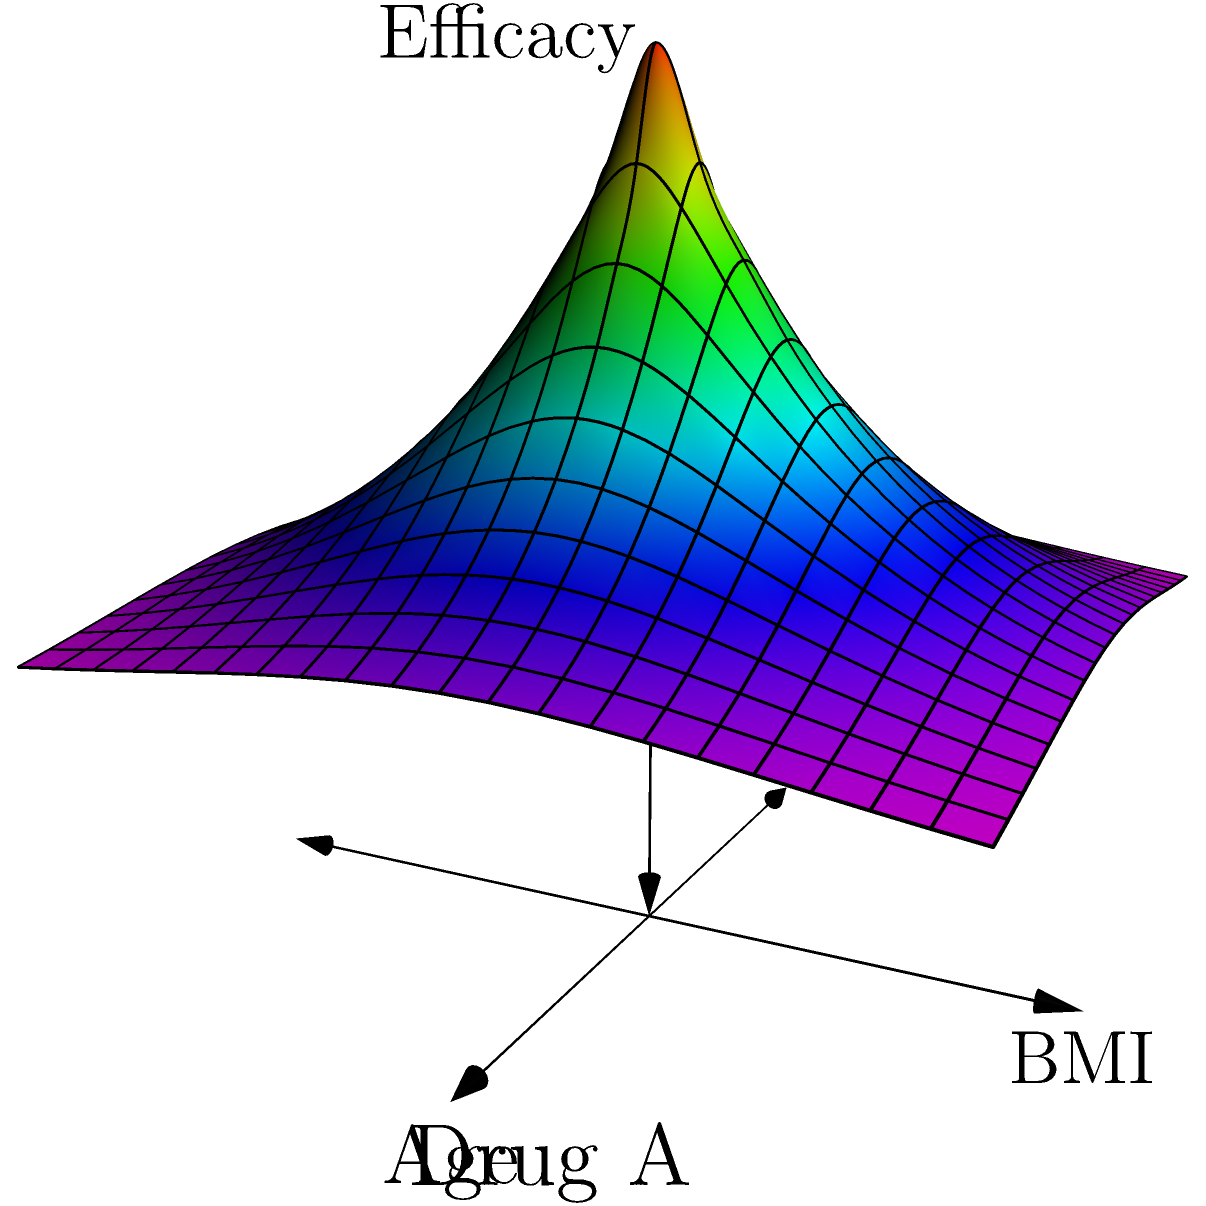In the multi-dimensional vector plot shown, which patient demographic characteristic appears to have the most significant impact on the efficacy of Drug A? To determine which patient demographic characteristic has the most significant impact on Drug A's efficacy, we need to analyze the 3D plot carefully:

1. The x-axis represents Age, the y-axis represents BMI (Body Mass Index), and the z-axis represents Efficacy.

2. The surface plot shows the relationship between these three variables for Drug A.

3. Observe the gradient of colors: 
   - Red indicates high efficacy
   - Blue indicates low efficacy

4. Looking at the age axis (x-axis):
   - There's a gradual change in efficacy as age increases or decreases
   - The change is relatively smooth and consistent

5. Examining the BMI axis (y-axis):
   - There's a more pronounced change in efficacy as BMI changes
   - The peak efficacy (red area) is concentrated in the middle BMI range
   - Efficacy drops sharply (turns blue) for both low and high BMI values

6. The surface's shape and color distribution show a more dramatic change along the BMI axis compared to the Age axis.

Therefore, based on this plot, BMI appears to have a more significant impact on Drug A's efficacy than Age. The efficacy is highest for patients with average BMI and decreases notably for patients with very low or very high BMI.
Answer: BMI (Body Mass Index) 